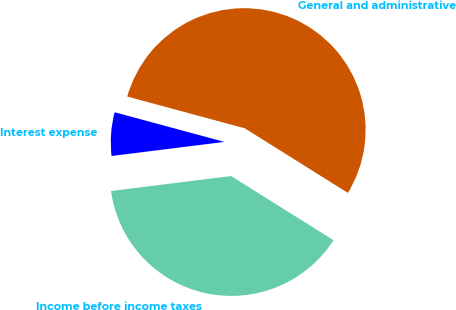Convert chart to OTSL. <chart><loc_0><loc_0><loc_500><loc_500><pie_chart><fcel>General and administrative<fcel>Interest expense<fcel>Income before income taxes<nl><fcel>54.7%<fcel>6.18%<fcel>39.11%<nl></chart> 